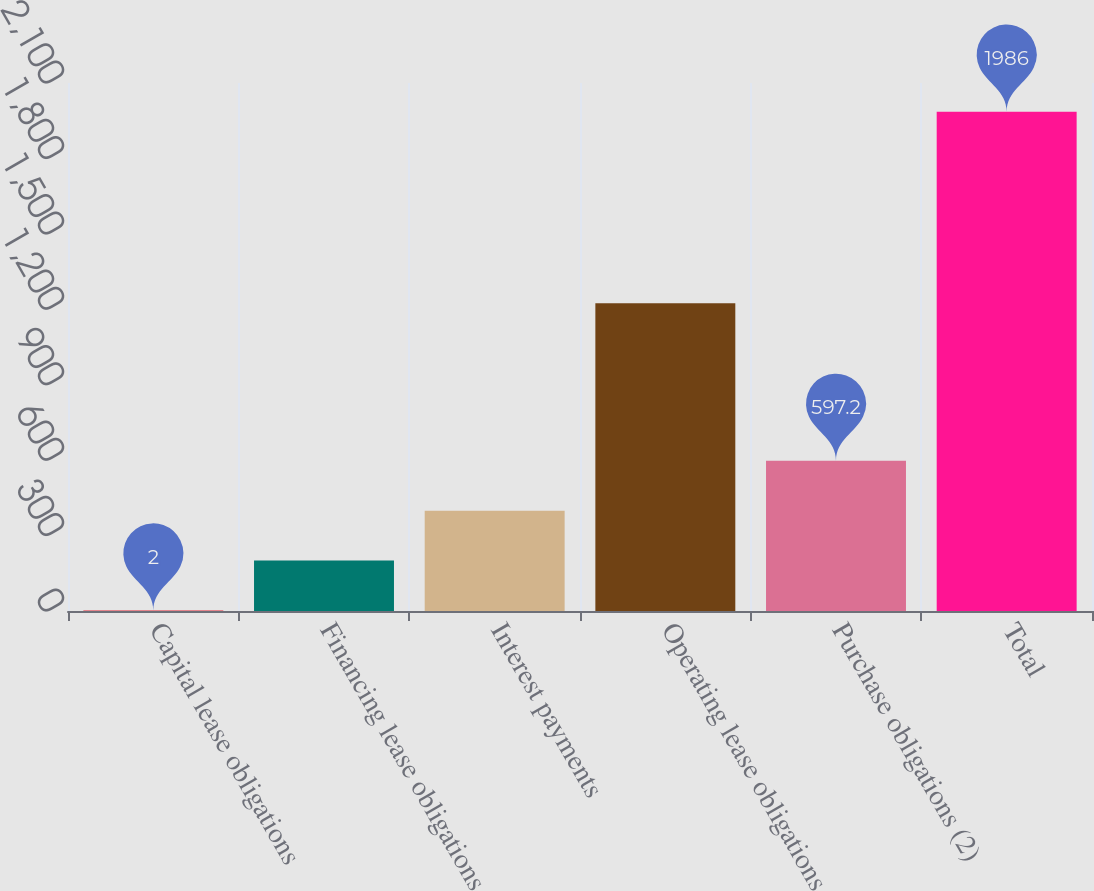Convert chart to OTSL. <chart><loc_0><loc_0><loc_500><loc_500><bar_chart><fcel>Capital lease obligations<fcel>Financing lease obligations<fcel>Interest payments<fcel>Operating lease obligations<fcel>Purchase obligations (2)<fcel>Total<nl><fcel>2<fcel>200.4<fcel>398.8<fcel>1224<fcel>597.2<fcel>1986<nl></chart> 